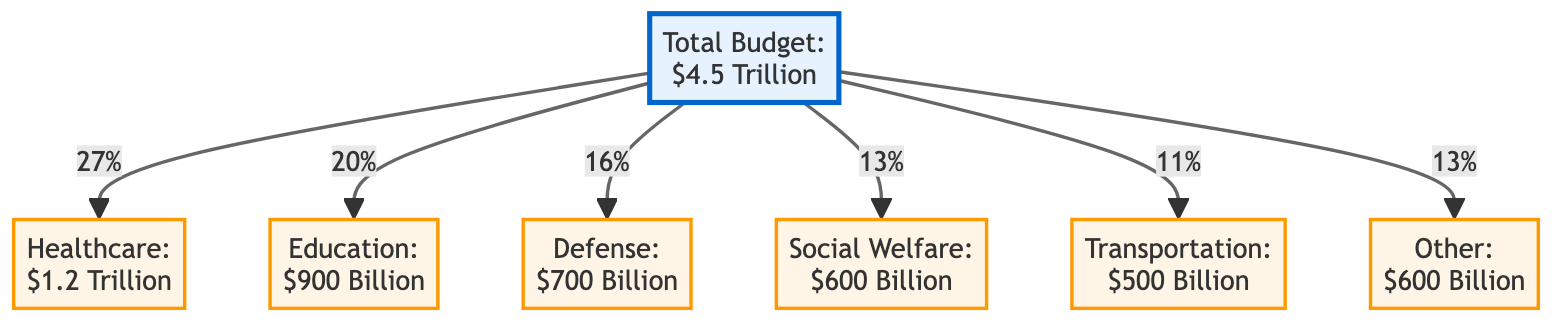What is the total budget allocation for the fiscal year 2023? The total budget allocation is explicitly stated in the diagram as $4.5 Trillion.
Answer: $4.5 Trillion How much is allocated to healthcare? The diagram specifically indicates that the allocation for healthcare is $1.2 Trillion.
Answer: $1.2 Trillion Which sector receives the least funding? By analyzing the allocations, transportation and other sectors both receive $500 Billion, which are the lowest amounts in the diagram.
Answer: Transportation or Other What percentage of the total budget is allocated to defense? The diagram shows that the budget allocation for defense is represented as 16% of the total budget.
Answer: 16% What is the total funding allocated to education and welfare combined? To find this, add the education allocation of $900 Billion and the welfare allocation of $600 Billion, resulting in $1.5 Trillion combined.
Answer: $1.5 Trillion Which sector's allocation is equal to the sum of transportation and welfare? Tasked with identifying this, we note that transportation is $500 Billion and welfare is $600 Billion, totaling $1.1 Trillion. The healthcare sector, which is at $1.2 Trillion, is not equal, so the other sector does not match as it is also $600 Billion. Hence education, which is at $900 Billion, does not either. The answer will not match any sector exactly, but if none strictly matches would be non-compliant due to the values shown.
Answer: None matches exactly What is the combined percentage allocation for healthcare and education? First, sum the percentages given for healthcare (27%) and education (20%), yielding a total of 47% for these sectors combined.
Answer: 47% How many sectors are represented in the diagram? By counting, there are a total of six sectors listed in the diagram, including healthcare, education, defense, welfare, transportation, and other.
Answer: 6 